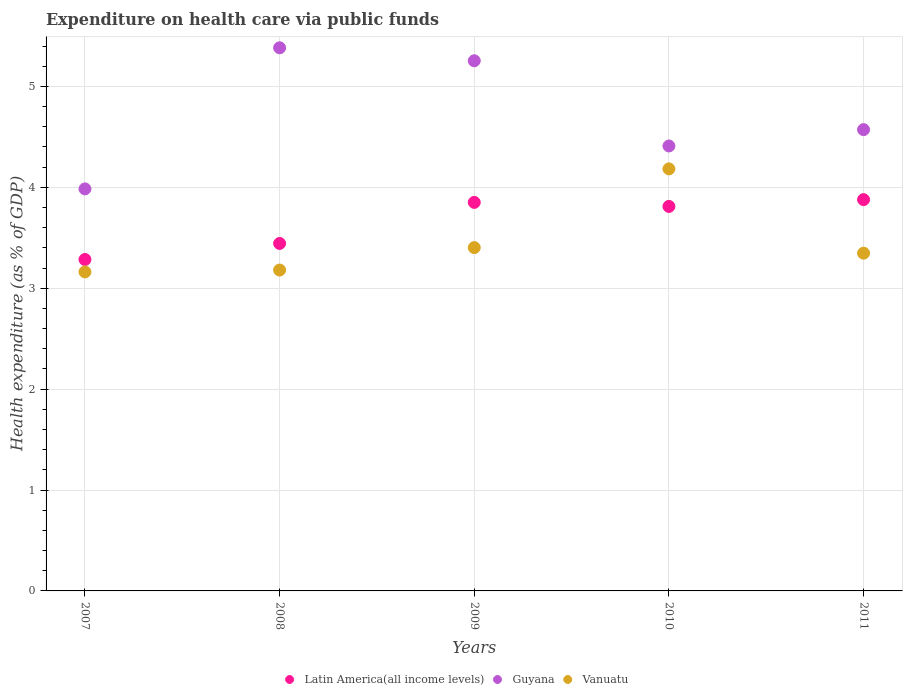How many different coloured dotlines are there?
Offer a terse response. 3. What is the expenditure made on health care in Guyana in 2009?
Give a very brief answer. 5.25. Across all years, what is the maximum expenditure made on health care in Guyana?
Your answer should be compact. 5.38. Across all years, what is the minimum expenditure made on health care in Guyana?
Give a very brief answer. 3.98. In which year was the expenditure made on health care in Guyana maximum?
Your answer should be compact. 2008. What is the total expenditure made on health care in Vanuatu in the graph?
Give a very brief answer. 17.27. What is the difference between the expenditure made on health care in Vanuatu in 2007 and that in 2010?
Your answer should be very brief. -1.02. What is the difference between the expenditure made on health care in Guyana in 2011 and the expenditure made on health care in Latin America(all income levels) in 2009?
Keep it short and to the point. 0.72. What is the average expenditure made on health care in Vanuatu per year?
Offer a terse response. 3.45. In the year 2008, what is the difference between the expenditure made on health care in Latin America(all income levels) and expenditure made on health care in Vanuatu?
Your answer should be compact. 0.26. What is the ratio of the expenditure made on health care in Latin America(all income levels) in 2007 to that in 2008?
Your answer should be very brief. 0.95. Is the expenditure made on health care in Guyana in 2009 less than that in 2011?
Ensure brevity in your answer.  No. What is the difference between the highest and the second highest expenditure made on health care in Vanuatu?
Your answer should be compact. 0.78. What is the difference between the highest and the lowest expenditure made on health care in Guyana?
Ensure brevity in your answer.  1.4. In how many years, is the expenditure made on health care in Latin America(all income levels) greater than the average expenditure made on health care in Latin America(all income levels) taken over all years?
Your answer should be compact. 3. Is it the case that in every year, the sum of the expenditure made on health care in Guyana and expenditure made on health care in Vanuatu  is greater than the expenditure made on health care in Latin America(all income levels)?
Offer a terse response. Yes. Does the expenditure made on health care in Guyana monotonically increase over the years?
Make the answer very short. No. How many years are there in the graph?
Ensure brevity in your answer.  5. Are the values on the major ticks of Y-axis written in scientific E-notation?
Give a very brief answer. No. Does the graph contain any zero values?
Your answer should be very brief. No. What is the title of the graph?
Your response must be concise. Expenditure on health care via public funds. Does "Bolivia" appear as one of the legend labels in the graph?
Make the answer very short. No. What is the label or title of the Y-axis?
Make the answer very short. Health expenditure (as % of GDP). What is the Health expenditure (as % of GDP) in Latin America(all income levels) in 2007?
Your response must be concise. 3.28. What is the Health expenditure (as % of GDP) of Guyana in 2007?
Ensure brevity in your answer.  3.98. What is the Health expenditure (as % of GDP) in Vanuatu in 2007?
Give a very brief answer. 3.16. What is the Health expenditure (as % of GDP) of Latin America(all income levels) in 2008?
Provide a short and direct response. 3.44. What is the Health expenditure (as % of GDP) of Guyana in 2008?
Offer a terse response. 5.38. What is the Health expenditure (as % of GDP) of Vanuatu in 2008?
Offer a terse response. 3.18. What is the Health expenditure (as % of GDP) in Latin America(all income levels) in 2009?
Offer a terse response. 3.85. What is the Health expenditure (as % of GDP) of Guyana in 2009?
Make the answer very short. 5.25. What is the Health expenditure (as % of GDP) in Vanuatu in 2009?
Provide a short and direct response. 3.4. What is the Health expenditure (as % of GDP) in Latin America(all income levels) in 2010?
Keep it short and to the point. 3.81. What is the Health expenditure (as % of GDP) in Guyana in 2010?
Your response must be concise. 4.41. What is the Health expenditure (as % of GDP) of Vanuatu in 2010?
Provide a short and direct response. 4.18. What is the Health expenditure (as % of GDP) of Latin America(all income levels) in 2011?
Your answer should be compact. 3.88. What is the Health expenditure (as % of GDP) of Guyana in 2011?
Give a very brief answer. 4.57. What is the Health expenditure (as % of GDP) in Vanuatu in 2011?
Offer a very short reply. 3.35. Across all years, what is the maximum Health expenditure (as % of GDP) in Latin America(all income levels)?
Provide a short and direct response. 3.88. Across all years, what is the maximum Health expenditure (as % of GDP) of Guyana?
Your answer should be very brief. 5.38. Across all years, what is the maximum Health expenditure (as % of GDP) of Vanuatu?
Give a very brief answer. 4.18. Across all years, what is the minimum Health expenditure (as % of GDP) of Latin America(all income levels)?
Give a very brief answer. 3.28. Across all years, what is the minimum Health expenditure (as % of GDP) of Guyana?
Your response must be concise. 3.98. Across all years, what is the minimum Health expenditure (as % of GDP) in Vanuatu?
Give a very brief answer. 3.16. What is the total Health expenditure (as % of GDP) of Latin America(all income levels) in the graph?
Offer a terse response. 18.27. What is the total Health expenditure (as % of GDP) of Guyana in the graph?
Make the answer very short. 23.6. What is the total Health expenditure (as % of GDP) of Vanuatu in the graph?
Offer a terse response. 17.27. What is the difference between the Health expenditure (as % of GDP) in Latin America(all income levels) in 2007 and that in 2008?
Your answer should be compact. -0.16. What is the difference between the Health expenditure (as % of GDP) of Guyana in 2007 and that in 2008?
Make the answer very short. -1.4. What is the difference between the Health expenditure (as % of GDP) in Vanuatu in 2007 and that in 2008?
Give a very brief answer. -0.02. What is the difference between the Health expenditure (as % of GDP) of Latin America(all income levels) in 2007 and that in 2009?
Your answer should be compact. -0.57. What is the difference between the Health expenditure (as % of GDP) of Guyana in 2007 and that in 2009?
Give a very brief answer. -1.27. What is the difference between the Health expenditure (as % of GDP) of Vanuatu in 2007 and that in 2009?
Give a very brief answer. -0.24. What is the difference between the Health expenditure (as % of GDP) in Latin America(all income levels) in 2007 and that in 2010?
Your response must be concise. -0.53. What is the difference between the Health expenditure (as % of GDP) of Guyana in 2007 and that in 2010?
Your answer should be compact. -0.43. What is the difference between the Health expenditure (as % of GDP) of Vanuatu in 2007 and that in 2010?
Give a very brief answer. -1.02. What is the difference between the Health expenditure (as % of GDP) in Latin America(all income levels) in 2007 and that in 2011?
Offer a very short reply. -0.59. What is the difference between the Health expenditure (as % of GDP) in Guyana in 2007 and that in 2011?
Your response must be concise. -0.59. What is the difference between the Health expenditure (as % of GDP) in Vanuatu in 2007 and that in 2011?
Your response must be concise. -0.19. What is the difference between the Health expenditure (as % of GDP) in Latin America(all income levels) in 2008 and that in 2009?
Give a very brief answer. -0.41. What is the difference between the Health expenditure (as % of GDP) in Guyana in 2008 and that in 2009?
Provide a short and direct response. 0.13. What is the difference between the Health expenditure (as % of GDP) in Vanuatu in 2008 and that in 2009?
Your answer should be very brief. -0.22. What is the difference between the Health expenditure (as % of GDP) in Latin America(all income levels) in 2008 and that in 2010?
Your answer should be very brief. -0.37. What is the difference between the Health expenditure (as % of GDP) in Guyana in 2008 and that in 2010?
Provide a short and direct response. 0.97. What is the difference between the Health expenditure (as % of GDP) of Vanuatu in 2008 and that in 2010?
Your answer should be very brief. -1. What is the difference between the Health expenditure (as % of GDP) in Latin America(all income levels) in 2008 and that in 2011?
Offer a very short reply. -0.43. What is the difference between the Health expenditure (as % of GDP) of Guyana in 2008 and that in 2011?
Give a very brief answer. 0.81. What is the difference between the Health expenditure (as % of GDP) in Vanuatu in 2008 and that in 2011?
Keep it short and to the point. -0.17. What is the difference between the Health expenditure (as % of GDP) of Guyana in 2009 and that in 2010?
Provide a short and direct response. 0.84. What is the difference between the Health expenditure (as % of GDP) of Vanuatu in 2009 and that in 2010?
Provide a short and direct response. -0.78. What is the difference between the Health expenditure (as % of GDP) in Latin America(all income levels) in 2009 and that in 2011?
Give a very brief answer. -0.03. What is the difference between the Health expenditure (as % of GDP) in Guyana in 2009 and that in 2011?
Make the answer very short. 0.68. What is the difference between the Health expenditure (as % of GDP) in Vanuatu in 2009 and that in 2011?
Give a very brief answer. 0.06. What is the difference between the Health expenditure (as % of GDP) in Latin America(all income levels) in 2010 and that in 2011?
Provide a succinct answer. -0.07. What is the difference between the Health expenditure (as % of GDP) of Guyana in 2010 and that in 2011?
Offer a terse response. -0.16. What is the difference between the Health expenditure (as % of GDP) in Vanuatu in 2010 and that in 2011?
Provide a succinct answer. 0.84. What is the difference between the Health expenditure (as % of GDP) in Latin America(all income levels) in 2007 and the Health expenditure (as % of GDP) in Guyana in 2008?
Offer a very short reply. -2.1. What is the difference between the Health expenditure (as % of GDP) of Latin America(all income levels) in 2007 and the Health expenditure (as % of GDP) of Vanuatu in 2008?
Give a very brief answer. 0.1. What is the difference between the Health expenditure (as % of GDP) of Guyana in 2007 and the Health expenditure (as % of GDP) of Vanuatu in 2008?
Offer a very short reply. 0.8. What is the difference between the Health expenditure (as % of GDP) of Latin America(all income levels) in 2007 and the Health expenditure (as % of GDP) of Guyana in 2009?
Make the answer very short. -1.97. What is the difference between the Health expenditure (as % of GDP) of Latin America(all income levels) in 2007 and the Health expenditure (as % of GDP) of Vanuatu in 2009?
Your response must be concise. -0.12. What is the difference between the Health expenditure (as % of GDP) in Guyana in 2007 and the Health expenditure (as % of GDP) in Vanuatu in 2009?
Give a very brief answer. 0.58. What is the difference between the Health expenditure (as % of GDP) of Latin America(all income levels) in 2007 and the Health expenditure (as % of GDP) of Guyana in 2010?
Give a very brief answer. -1.12. What is the difference between the Health expenditure (as % of GDP) of Latin America(all income levels) in 2007 and the Health expenditure (as % of GDP) of Vanuatu in 2010?
Give a very brief answer. -0.9. What is the difference between the Health expenditure (as % of GDP) in Guyana in 2007 and the Health expenditure (as % of GDP) in Vanuatu in 2010?
Your response must be concise. -0.2. What is the difference between the Health expenditure (as % of GDP) of Latin America(all income levels) in 2007 and the Health expenditure (as % of GDP) of Guyana in 2011?
Keep it short and to the point. -1.29. What is the difference between the Health expenditure (as % of GDP) of Latin America(all income levels) in 2007 and the Health expenditure (as % of GDP) of Vanuatu in 2011?
Offer a terse response. -0.06. What is the difference between the Health expenditure (as % of GDP) of Guyana in 2007 and the Health expenditure (as % of GDP) of Vanuatu in 2011?
Make the answer very short. 0.64. What is the difference between the Health expenditure (as % of GDP) in Latin America(all income levels) in 2008 and the Health expenditure (as % of GDP) in Guyana in 2009?
Provide a short and direct response. -1.81. What is the difference between the Health expenditure (as % of GDP) of Latin America(all income levels) in 2008 and the Health expenditure (as % of GDP) of Vanuatu in 2009?
Give a very brief answer. 0.04. What is the difference between the Health expenditure (as % of GDP) of Guyana in 2008 and the Health expenditure (as % of GDP) of Vanuatu in 2009?
Provide a succinct answer. 1.98. What is the difference between the Health expenditure (as % of GDP) of Latin America(all income levels) in 2008 and the Health expenditure (as % of GDP) of Guyana in 2010?
Your answer should be compact. -0.97. What is the difference between the Health expenditure (as % of GDP) of Latin America(all income levels) in 2008 and the Health expenditure (as % of GDP) of Vanuatu in 2010?
Provide a succinct answer. -0.74. What is the difference between the Health expenditure (as % of GDP) in Guyana in 2008 and the Health expenditure (as % of GDP) in Vanuatu in 2010?
Provide a succinct answer. 1.2. What is the difference between the Health expenditure (as % of GDP) in Latin America(all income levels) in 2008 and the Health expenditure (as % of GDP) in Guyana in 2011?
Keep it short and to the point. -1.13. What is the difference between the Health expenditure (as % of GDP) in Latin America(all income levels) in 2008 and the Health expenditure (as % of GDP) in Vanuatu in 2011?
Your answer should be very brief. 0.1. What is the difference between the Health expenditure (as % of GDP) in Guyana in 2008 and the Health expenditure (as % of GDP) in Vanuatu in 2011?
Make the answer very short. 2.04. What is the difference between the Health expenditure (as % of GDP) of Latin America(all income levels) in 2009 and the Health expenditure (as % of GDP) of Guyana in 2010?
Your answer should be compact. -0.56. What is the difference between the Health expenditure (as % of GDP) of Latin America(all income levels) in 2009 and the Health expenditure (as % of GDP) of Vanuatu in 2010?
Your answer should be compact. -0.33. What is the difference between the Health expenditure (as % of GDP) in Guyana in 2009 and the Health expenditure (as % of GDP) in Vanuatu in 2010?
Offer a terse response. 1.07. What is the difference between the Health expenditure (as % of GDP) of Latin America(all income levels) in 2009 and the Health expenditure (as % of GDP) of Guyana in 2011?
Your answer should be very brief. -0.72. What is the difference between the Health expenditure (as % of GDP) in Latin America(all income levels) in 2009 and the Health expenditure (as % of GDP) in Vanuatu in 2011?
Give a very brief answer. 0.5. What is the difference between the Health expenditure (as % of GDP) of Guyana in 2009 and the Health expenditure (as % of GDP) of Vanuatu in 2011?
Offer a terse response. 1.91. What is the difference between the Health expenditure (as % of GDP) of Latin America(all income levels) in 2010 and the Health expenditure (as % of GDP) of Guyana in 2011?
Your answer should be very brief. -0.76. What is the difference between the Health expenditure (as % of GDP) in Latin America(all income levels) in 2010 and the Health expenditure (as % of GDP) in Vanuatu in 2011?
Offer a very short reply. 0.46. What is the difference between the Health expenditure (as % of GDP) of Guyana in 2010 and the Health expenditure (as % of GDP) of Vanuatu in 2011?
Offer a terse response. 1.06. What is the average Health expenditure (as % of GDP) in Latin America(all income levels) per year?
Make the answer very short. 3.65. What is the average Health expenditure (as % of GDP) of Guyana per year?
Offer a very short reply. 4.72. What is the average Health expenditure (as % of GDP) in Vanuatu per year?
Offer a terse response. 3.45. In the year 2007, what is the difference between the Health expenditure (as % of GDP) in Latin America(all income levels) and Health expenditure (as % of GDP) in Guyana?
Provide a succinct answer. -0.7. In the year 2007, what is the difference between the Health expenditure (as % of GDP) in Latin America(all income levels) and Health expenditure (as % of GDP) in Vanuatu?
Keep it short and to the point. 0.12. In the year 2007, what is the difference between the Health expenditure (as % of GDP) of Guyana and Health expenditure (as % of GDP) of Vanuatu?
Provide a succinct answer. 0.82. In the year 2008, what is the difference between the Health expenditure (as % of GDP) in Latin America(all income levels) and Health expenditure (as % of GDP) in Guyana?
Give a very brief answer. -1.94. In the year 2008, what is the difference between the Health expenditure (as % of GDP) of Latin America(all income levels) and Health expenditure (as % of GDP) of Vanuatu?
Your answer should be compact. 0.26. In the year 2008, what is the difference between the Health expenditure (as % of GDP) in Guyana and Health expenditure (as % of GDP) in Vanuatu?
Give a very brief answer. 2.2. In the year 2009, what is the difference between the Health expenditure (as % of GDP) in Latin America(all income levels) and Health expenditure (as % of GDP) in Guyana?
Your response must be concise. -1.4. In the year 2009, what is the difference between the Health expenditure (as % of GDP) of Latin America(all income levels) and Health expenditure (as % of GDP) of Vanuatu?
Keep it short and to the point. 0.45. In the year 2009, what is the difference between the Health expenditure (as % of GDP) of Guyana and Health expenditure (as % of GDP) of Vanuatu?
Offer a terse response. 1.85. In the year 2010, what is the difference between the Health expenditure (as % of GDP) of Latin America(all income levels) and Health expenditure (as % of GDP) of Guyana?
Your response must be concise. -0.6. In the year 2010, what is the difference between the Health expenditure (as % of GDP) of Latin America(all income levels) and Health expenditure (as % of GDP) of Vanuatu?
Keep it short and to the point. -0.37. In the year 2010, what is the difference between the Health expenditure (as % of GDP) of Guyana and Health expenditure (as % of GDP) of Vanuatu?
Your answer should be compact. 0.23. In the year 2011, what is the difference between the Health expenditure (as % of GDP) of Latin America(all income levels) and Health expenditure (as % of GDP) of Guyana?
Your answer should be very brief. -0.69. In the year 2011, what is the difference between the Health expenditure (as % of GDP) of Latin America(all income levels) and Health expenditure (as % of GDP) of Vanuatu?
Provide a short and direct response. 0.53. In the year 2011, what is the difference between the Health expenditure (as % of GDP) of Guyana and Health expenditure (as % of GDP) of Vanuatu?
Your response must be concise. 1.22. What is the ratio of the Health expenditure (as % of GDP) of Latin America(all income levels) in 2007 to that in 2008?
Ensure brevity in your answer.  0.95. What is the ratio of the Health expenditure (as % of GDP) of Guyana in 2007 to that in 2008?
Offer a terse response. 0.74. What is the ratio of the Health expenditure (as % of GDP) of Latin America(all income levels) in 2007 to that in 2009?
Your answer should be compact. 0.85. What is the ratio of the Health expenditure (as % of GDP) in Guyana in 2007 to that in 2009?
Your answer should be compact. 0.76. What is the ratio of the Health expenditure (as % of GDP) of Vanuatu in 2007 to that in 2009?
Provide a succinct answer. 0.93. What is the ratio of the Health expenditure (as % of GDP) in Latin America(all income levels) in 2007 to that in 2010?
Provide a succinct answer. 0.86. What is the ratio of the Health expenditure (as % of GDP) of Guyana in 2007 to that in 2010?
Your answer should be very brief. 0.9. What is the ratio of the Health expenditure (as % of GDP) of Vanuatu in 2007 to that in 2010?
Offer a very short reply. 0.76. What is the ratio of the Health expenditure (as % of GDP) of Latin America(all income levels) in 2007 to that in 2011?
Give a very brief answer. 0.85. What is the ratio of the Health expenditure (as % of GDP) of Guyana in 2007 to that in 2011?
Keep it short and to the point. 0.87. What is the ratio of the Health expenditure (as % of GDP) in Vanuatu in 2007 to that in 2011?
Make the answer very short. 0.94. What is the ratio of the Health expenditure (as % of GDP) in Latin America(all income levels) in 2008 to that in 2009?
Your response must be concise. 0.89. What is the ratio of the Health expenditure (as % of GDP) in Guyana in 2008 to that in 2009?
Your response must be concise. 1.02. What is the ratio of the Health expenditure (as % of GDP) of Vanuatu in 2008 to that in 2009?
Keep it short and to the point. 0.93. What is the ratio of the Health expenditure (as % of GDP) in Latin America(all income levels) in 2008 to that in 2010?
Provide a succinct answer. 0.9. What is the ratio of the Health expenditure (as % of GDP) in Guyana in 2008 to that in 2010?
Your answer should be very brief. 1.22. What is the ratio of the Health expenditure (as % of GDP) in Vanuatu in 2008 to that in 2010?
Offer a very short reply. 0.76. What is the ratio of the Health expenditure (as % of GDP) of Latin America(all income levels) in 2008 to that in 2011?
Your response must be concise. 0.89. What is the ratio of the Health expenditure (as % of GDP) in Guyana in 2008 to that in 2011?
Your response must be concise. 1.18. What is the ratio of the Health expenditure (as % of GDP) of Latin America(all income levels) in 2009 to that in 2010?
Offer a terse response. 1.01. What is the ratio of the Health expenditure (as % of GDP) in Guyana in 2009 to that in 2010?
Offer a terse response. 1.19. What is the ratio of the Health expenditure (as % of GDP) in Vanuatu in 2009 to that in 2010?
Make the answer very short. 0.81. What is the ratio of the Health expenditure (as % of GDP) of Latin America(all income levels) in 2009 to that in 2011?
Your response must be concise. 0.99. What is the ratio of the Health expenditure (as % of GDP) in Guyana in 2009 to that in 2011?
Provide a short and direct response. 1.15. What is the ratio of the Health expenditure (as % of GDP) in Vanuatu in 2009 to that in 2011?
Offer a very short reply. 1.02. What is the ratio of the Health expenditure (as % of GDP) in Latin America(all income levels) in 2010 to that in 2011?
Provide a short and direct response. 0.98. What is the ratio of the Health expenditure (as % of GDP) in Guyana in 2010 to that in 2011?
Offer a very short reply. 0.96. What is the ratio of the Health expenditure (as % of GDP) in Vanuatu in 2010 to that in 2011?
Make the answer very short. 1.25. What is the difference between the highest and the second highest Health expenditure (as % of GDP) in Latin America(all income levels)?
Make the answer very short. 0.03. What is the difference between the highest and the second highest Health expenditure (as % of GDP) in Guyana?
Your response must be concise. 0.13. What is the difference between the highest and the second highest Health expenditure (as % of GDP) of Vanuatu?
Give a very brief answer. 0.78. What is the difference between the highest and the lowest Health expenditure (as % of GDP) of Latin America(all income levels)?
Your response must be concise. 0.59. What is the difference between the highest and the lowest Health expenditure (as % of GDP) of Guyana?
Provide a short and direct response. 1.4. What is the difference between the highest and the lowest Health expenditure (as % of GDP) of Vanuatu?
Provide a short and direct response. 1.02. 